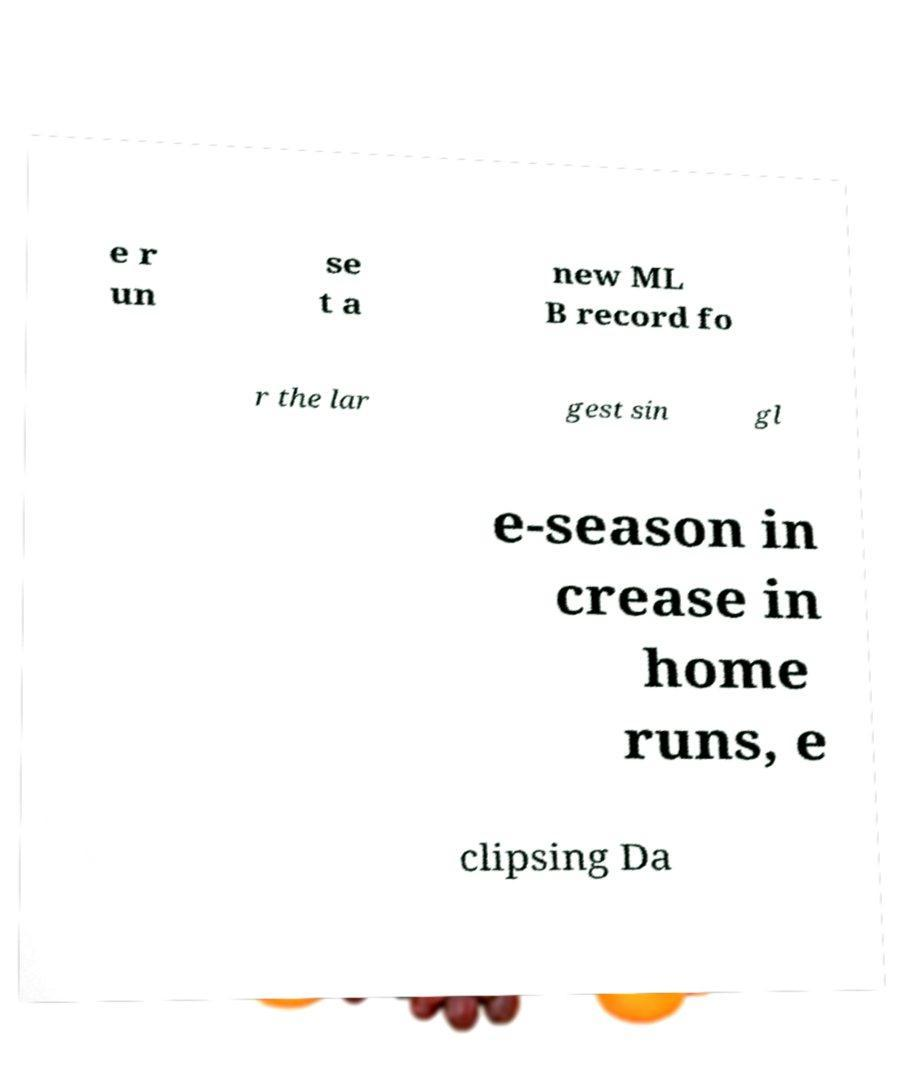Can you accurately transcribe the text from the provided image for me? e r un se t a new ML B record fo r the lar gest sin gl e-season in crease in home runs, e clipsing Da 